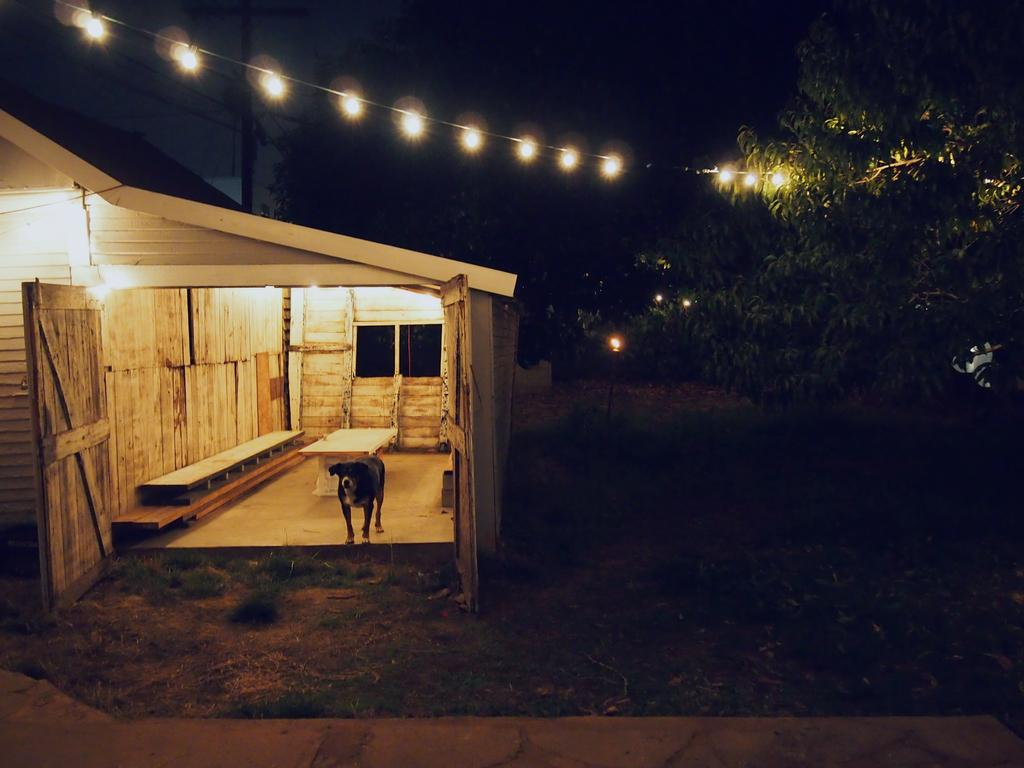What type of animal is in the image? There is a dog in the image. Where is the dog located in the room? The dog is standing in a wooden room. How many windows are visible behind the dog? There are two windows behind the dog. What furniture is present in the room? There is a table and a bench in the room. What can be seen on the right side of the image? Trees are visible on the right side of the image. What size tooth can be seen in the dog's mouth in the image? There is no tooth visible in the dog's mouth in the image. Is the dog displaying any signs of anger in the image? The dog's emotions cannot be determined from the image, as it does not show any facial expressions or body language indicative of anger. 